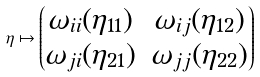<formula> <loc_0><loc_0><loc_500><loc_500>\eta \mapsto \begin{pmatrix} \omega _ { i i } ( \eta _ { 1 1 } ) & \omega _ { i j } ( \eta _ { 1 2 } ) \\ \omega _ { j i } ( \eta _ { 2 1 } ) & \omega _ { j j } ( \eta _ { 2 2 } ) \end{pmatrix}</formula> 